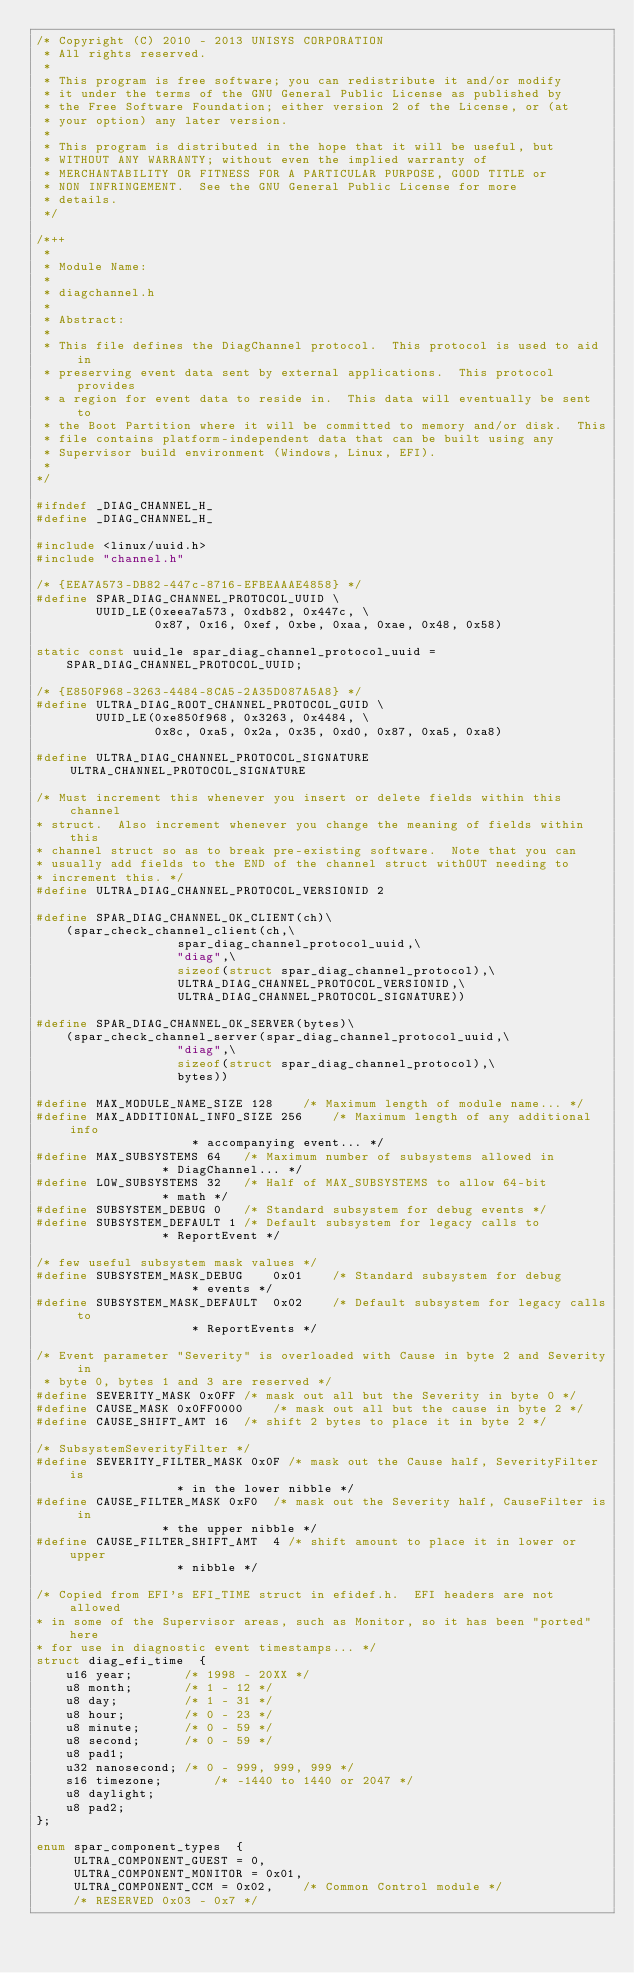Convert code to text. <code><loc_0><loc_0><loc_500><loc_500><_C_>/* Copyright (C) 2010 - 2013 UNISYS CORPORATION
 * All rights reserved.
 *
 * This program is free software; you can redistribute it and/or modify
 * it under the terms of the GNU General Public License as published by
 * the Free Software Foundation; either version 2 of the License, or (at
 * your option) any later version.
 *
 * This program is distributed in the hope that it will be useful, but
 * WITHOUT ANY WARRANTY; without even the implied warranty of
 * MERCHANTABILITY OR FITNESS FOR A PARTICULAR PURPOSE, GOOD TITLE or
 * NON INFRINGEMENT.  See the GNU General Public License for more
 * details.
 */

/*++
 *
 * Module Name:
 *
 * diagchannel.h
 *
 * Abstract:
 *
 * This file defines the DiagChannel protocol.  This protocol is used to aid in
 * preserving event data sent by external applications.  This protocol provides
 * a region for event data to reside in.  This data will eventually be sent to
 * the Boot Partition where it will be committed to memory and/or disk.  This
 * file contains platform-independent data that can be built using any
 * Supervisor build environment (Windows, Linux, EFI).
 *
*/

#ifndef _DIAG_CHANNEL_H_
#define _DIAG_CHANNEL_H_

#include <linux/uuid.h>
#include "channel.h"

/* {EEA7A573-DB82-447c-8716-EFBEAAAE4858} */
#define SPAR_DIAG_CHANNEL_PROTOCOL_UUID \
		UUID_LE(0xeea7a573, 0xdb82, 0x447c, \
				0x87, 0x16, 0xef, 0xbe, 0xaa, 0xae, 0x48, 0x58)

static const uuid_le spar_diag_channel_protocol_uuid =
	SPAR_DIAG_CHANNEL_PROTOCOL_UUID;

/* {E850F968-3263-4484-8CA5-2A35D087A5A8} */
#define ULTRA_DIAG_ROOT_CHANNEL_PROTOCOL_GUID \
		UUID_LE(0xe850f968, 0x3263, 0x4484, \
				0x8c, 0xa5, 0x2a, 0x35, 0xd0, 0x87, 0xa5, 0xa8)

#define ULTRA_DIAG_CHANNEL_PROTOCOL_SIGNATURE  ULTRA_CHANNEL_PROTOCOL_SIGNATURE

/* Must increment this whenever you insert or delete fields within this channel
* struct.  Also increment whenever you change the meaning of fields within this
* channel struct so as to break pre-existing software.  Note that you can
* usually add fields to the END of the channel struct withOUT needing to
* increment this. */
#define ULTRA_DIAG_CHANNEL_PROTOCOL_VERSIONID 2

#define SPAR_DIAG_CHANNEL_OK_CLIENT(ch)\
	(spar_check_channel_client(ch,\
				   spar_diag_channel_protocol_uuid,\
				   "diag",\
				   sizeof(struct spar_diag_channel_protocol),\
				   ULTRA_DIAG_CHANNEL_PROTOCOL_VERSIONID,\
				   ULTRA_DIAG_CHANNEL_PROTOCOL_SIGNATURE))

#define SPAR_DIAG_CHANNEL_OK_SERVER(bytes)\
	(spar_check_channel_server(spar_diag_channel_protocol_uuid,\
				   "diag",\
				   sizeof(struct spar_diag_channel_protocol),\
				   bytes))

#define MAX_MODULE_NAME_SIZE 128	/* Maximum length of module name... */
#define MAX_ADDITIONAL_INFO_SIZE 256	/* Maximum length of any additional info
					 * accompanying event... */
#define MAX_SUBSYSTEMS 64	/* Maximum number of subsystems allowed in
				 * DiagChannel... */
#define LOW_SUBSYSTEMS 32	/* Half of MAX_SUBSYSTEMS to allow 64-bit
				 * math */
#define SUBSYSTEM_DEBUG 0	/* Standard subsystem for debug events */
#define SUBSYSTEM_DEFAULT 1	/* Default subsystem for legacy calls to
				 * ReportEvent */

/* few useful subsystem mask values */
#define SUBSYSTEM_MASK_DEBUG	0x01	/* Standard subsystem for debug
					 * events */
#define SUBSYSTEM_MASK_DEFAULT  0x02	/* Default subsystem for legacy calls to
					 * ReportEvents */

/* Event parameter "Severity" is overloaded with Cause in byte 2 and Severity in
 * byte 0, bytes 1 and 3 are reserved */
#define SEVERITY_MASK 0x0FF	/* mask out all but the Severity in byte 0 */
#define CAUSE_MASK 0x0FF0000	/* mask out all but the cause in byte 2 */
#define CAUSE_SHIFT_AMT 16	/* shift 2 bytes to place it in byte 2 */

/* SubsystemSeverityFilter */
#define SEVERITY_FILTER_MASK 0x0F /* mask out the Cause half, SeverityFilter is
				   * in the lower nibble */
#define CAUSE_FILTER_MASK 0xF0	/* mask out the Severity half, CauseFilter is in
				 * the upper nibble */
#define CAUSE_FILTER_SHIFT_AMT	4 /* shift amount to place it in lower or upper
				   * nibble */

/* Copied from EFI's EFI_TIME struct in efidef.h.  EFI headers are not allowed
* in some of the Supervisor areas, such as Monitor, so it has been "ported" here
* for use in diagnostic event timestamps... */
struct diag_efi_time  {
	u16 year;		/* 1998 - 20XX */
	u8 month;		/* 1 - 12 */
	u8 day;			/* 1 - 31 */
	u8 hour;		/* 0 - 23 */
	u8 minute;		/* 0 - 59 */
	u8 second;		/* 0 - 59 */
	u8 pad1;
	u32 nanosecond;	/* 0 - 999, 999, 999 */
	s16 timezone;		/* -1440 to 1440 or 2047 */
	u8 daylight;
	u8 pad2;
};

enum spar_component_types  {
	 ULTRA_COMPONENT_GUEST = 0,
	 ULTRA_COMPONENT_MONITOR = 0x01,
	 ULTRA_COMPONENT_CCM = 0x02,	/* Common Control module */
	 /* RESERVED 0x03 - 0x7 */
</code> 